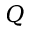Convert formula to latex. <formula><loc_0><loc_0><loc_500><loc_500>Q</formula> 